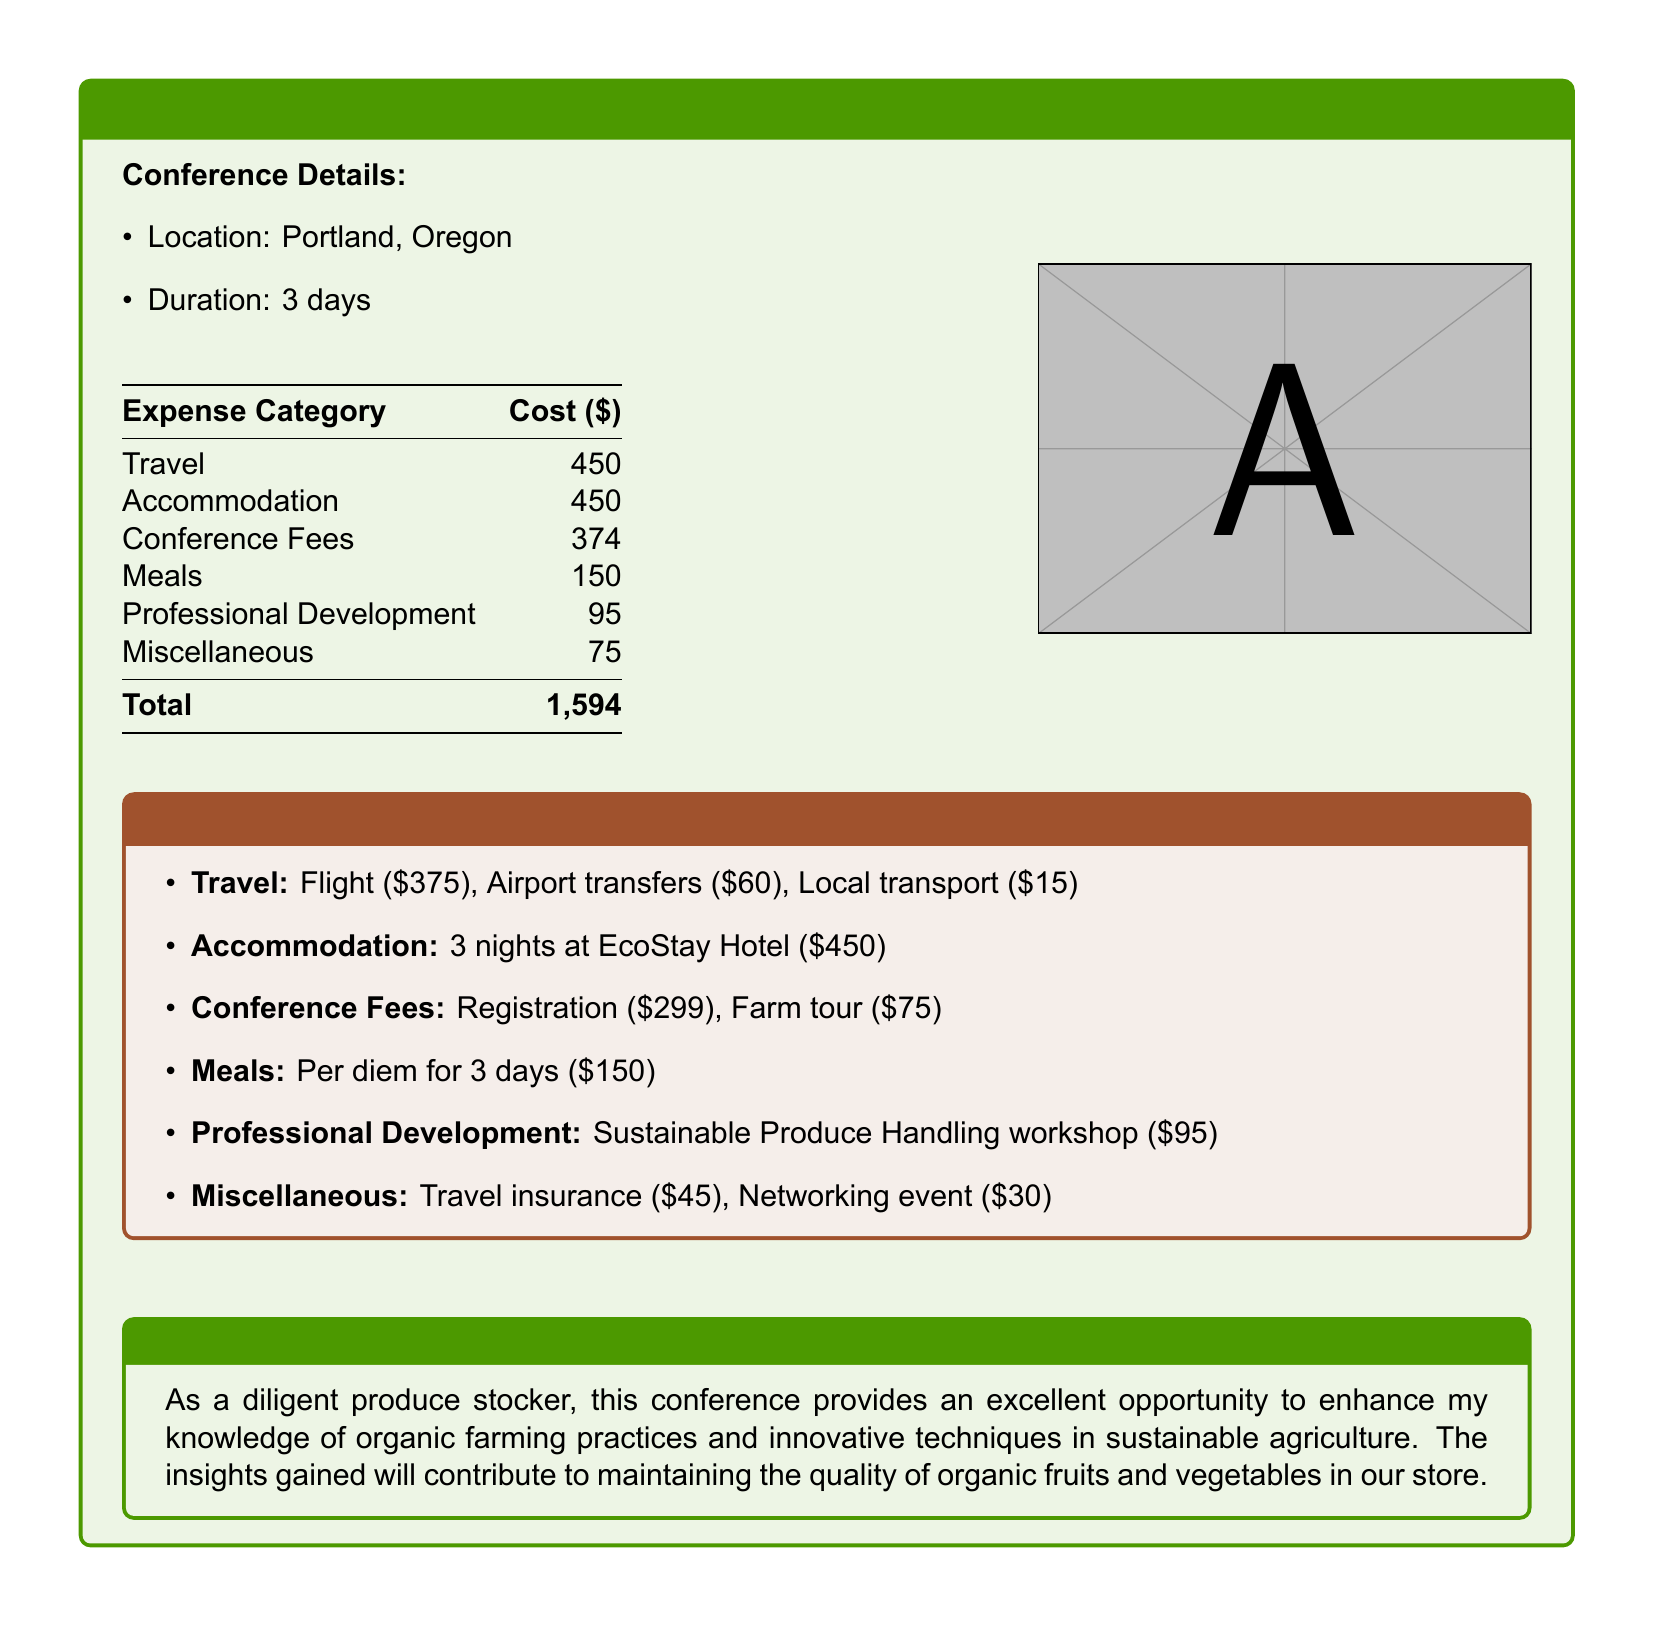What is the total estimated expense for the conference? The total estimated expense is calculated by summing all the individual expense categories listed in the budget.
Answer: 1,594 What are the travel expenses? The travel expenses include flight, airport transfers, and local transport, adding up to a total of $450.
Answer: 450 What is the cost of conference fees? The conference fees consist of registration and a farm tour, totaling $374.
Answer: 374 How many nights will accommodation be needed? The accommodation is for three nights at EcoStay Hotel.
Answer: 3 What is included in the professional development cost? The professional development cost covers a workshop on Sustainable Produce Handling, which is priced at $95.
Answer: $95 What is the per diem for meals during the conference? The meals expense represents the per diem for three days, totaling $150.
Answer: 150 How much is allocated for miscellaneous expenses? The budget allocates $75 for miscellaneous expenses, which includes travel insurance and a networking event.
Answer: 75 Where is the conference located? The document specifies that the conference will be held in Portland, Oregon.
Answer: Portland, Oregon What is the cost of the airport transfers? The airport transfers are listed at a cost of $60 in the travel expense breakdown.
Answer: $60 